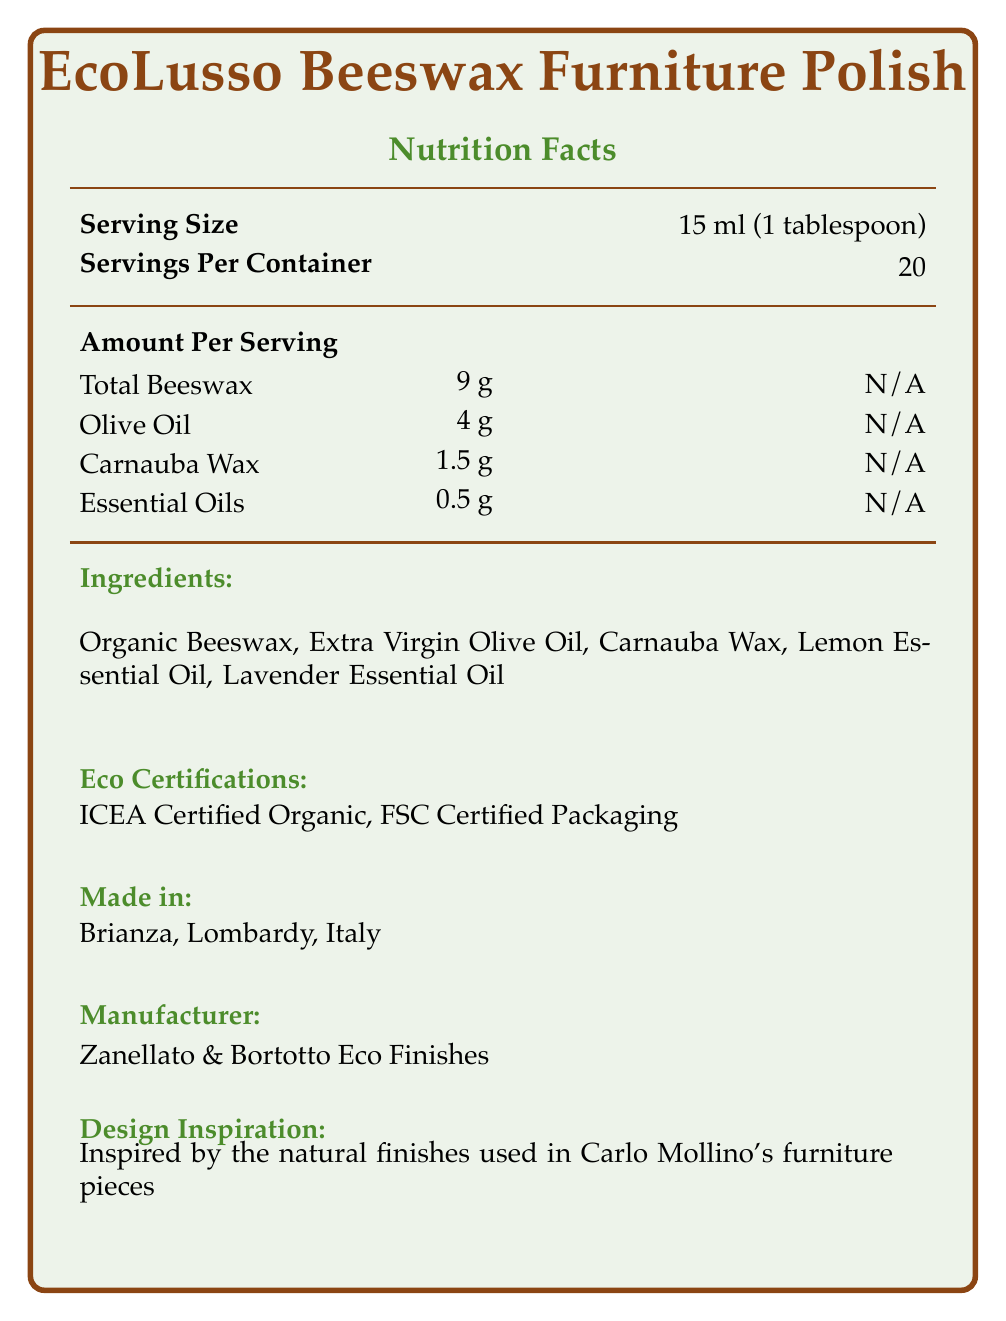what is the serving size of EcoLusso Beeswax Furniture Polish? The serving size is explicitly mentioned under the header "Serving Size."
Answer: 15 ml (1 tablespoon) how many servings are there per container of the furniture polish? The information "Servings Per Container" is provided directly in the document.
Answer: 20 what are the main ingredients in the EcoLusso Beeswax Furniture Polish? The ingredients are listed under the "Ingredients" section.
Answer: Organic Beeswax, Extra Virgin Olive Oil, Carnauba Wax, Lemon Essential Oil, Lavender Essential Oil where is the EcoLusso Beeswax Furniture Polish made? The "Made in" section clearly states the location as Brianza, Lombardy, Italy.
Answer: Brianza, Lombardy, Italy who is the manufacturer of this furniture polish? The "Manufacturer" section lists Zanellato & Bortotto Eco Finishes as the manufacturer.
Answer: Zanellato & Bortotto Eco Finishes what certifications does the EcoLusso Beeswax Furniture Polish have? The document lists these certifications under the "Eco Certifications" section.
Answer: ICEA Certified Organic, FSC Certified Packaging what is the total amount of beeswax per serving? The "Amount Per Serving" section provides this information for "Total Beeswax."
Answer: 9 g which of the following is not included as an ingredient in the EcoLusso Beeswax Furniture Polish? A. Carnauba Wax B. Olive Oil C. Coconut Oil D. Lemon Essential Oil Coconut Oil is not listed under the "Ingredients."
Answer: C. Coconut Oil which region of Italy does the design inspiration for EcoLusso Beeswax Furniture Polish come from? A. Lombardy B. Tuscany C. Veneto D. Sicily The document states the product is made in Brianza, Lombardy, Italy, linking the design inspiration to the Lombardy region.
Answer: A. Lombardy is the EcoLusso Beeswax Furniture Polish suitable for painted surfaces? The document explicitly states it is "Not Suitable For" painted surfaces.
Answer: No according to the document, what is the design inspiration for this product? This information is provided under the "Design Inspiration" section.
Answer: Inspired by the natural finishes used in Carlo Mollino's furniture pieces what should you use to buff the furniture after applying the EcoLusso Beeswax Furniture Polish? The usage instructions specify "Buff with a soft cloth for a natural shine."
Answer: A soft cloth how long is the shelf life of the EcoLusso Beeswax Furniture Polish? This is mentioned under the "Shelf Life" section.
Answer: 24 months from production date describe the main idea of the document. The document is a comprehensive overview of the EcoLusso Beeswax Furniture Polish, highlighting its eco-friendly nature, artisanal production, and Italian craftsmanship.
Answer: The document provides detailed information about EcoLusso Beeswax Furniture Polish, including its serving size, ingredients, nutritional facts, eco certifications, manufacturing details, design inspiration, usage instructions, storage recommendations, suitable and not suitable applications, and sustainability notes. The product is eco-friendly, Italian-made, and inspired by traditional furniture finishes. what is the storage recommendation for this furniture polish? The "Storage" section advises on the proper storage conditions.
Answer: Store in a cool, dry place away from direct sunlight. how much lemon essential oil is there per serving? The "Essential Oils" category in the "Amount Per Serving" section, which includes lemon essential oil, is listed as 0.5 g.
Answer: 0.5 g what is the artistic process behind the furniture polish? The "Artisanal Process" section details this information.
Answer: Hand-blended in small batches by master craftsmen in the tradition of Italian furniture making what is the total amount of oils (including olive and essential oils) per serving? Olive oil is 4 g and essential oils are 0.5 g, totaling 4.5 g.
Answer: 4.5 g what is the weight of the packaging? A. 5 g B. 10 g C. 20 g D. Not enough information The weight of the packaging is not mentioned in the document.
Answer: D. Not enough information where can you apply the EcoLusso Beeswax Furniture Polish? The suitable applications are listed under the "Suitable For" section.
Answer: Solid wood furniture, Wooden sculptures, Antique restoration, Cutting boards 